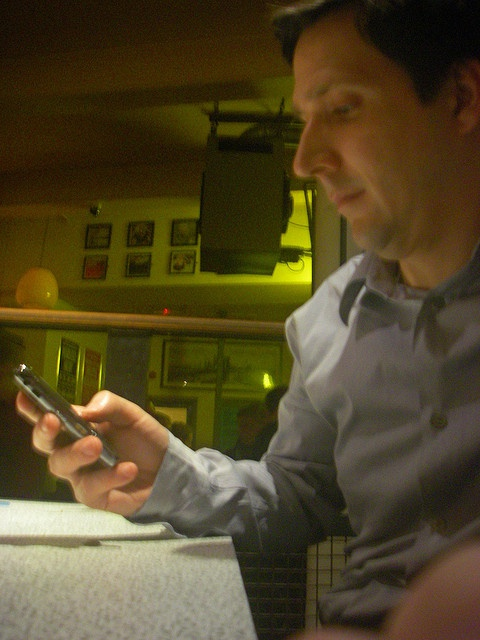Describe the objects in this image and their specific colors. I can see people in black, maroon, and gray tones, dining table in black, darkgray, gray, and beige tones, tv in black and darkgreen tones, and cell phone in black, olive, and gray tones in this image. 